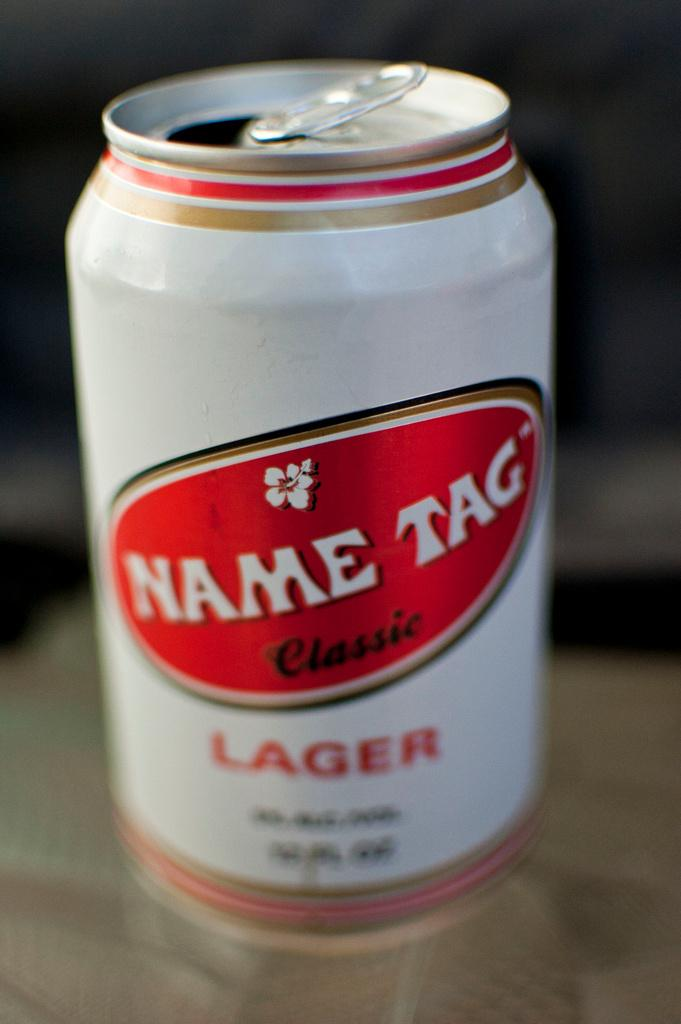<image>
Summarize the visual content of the image. A can of Name Tag classic lager is white with red and gold accents. 